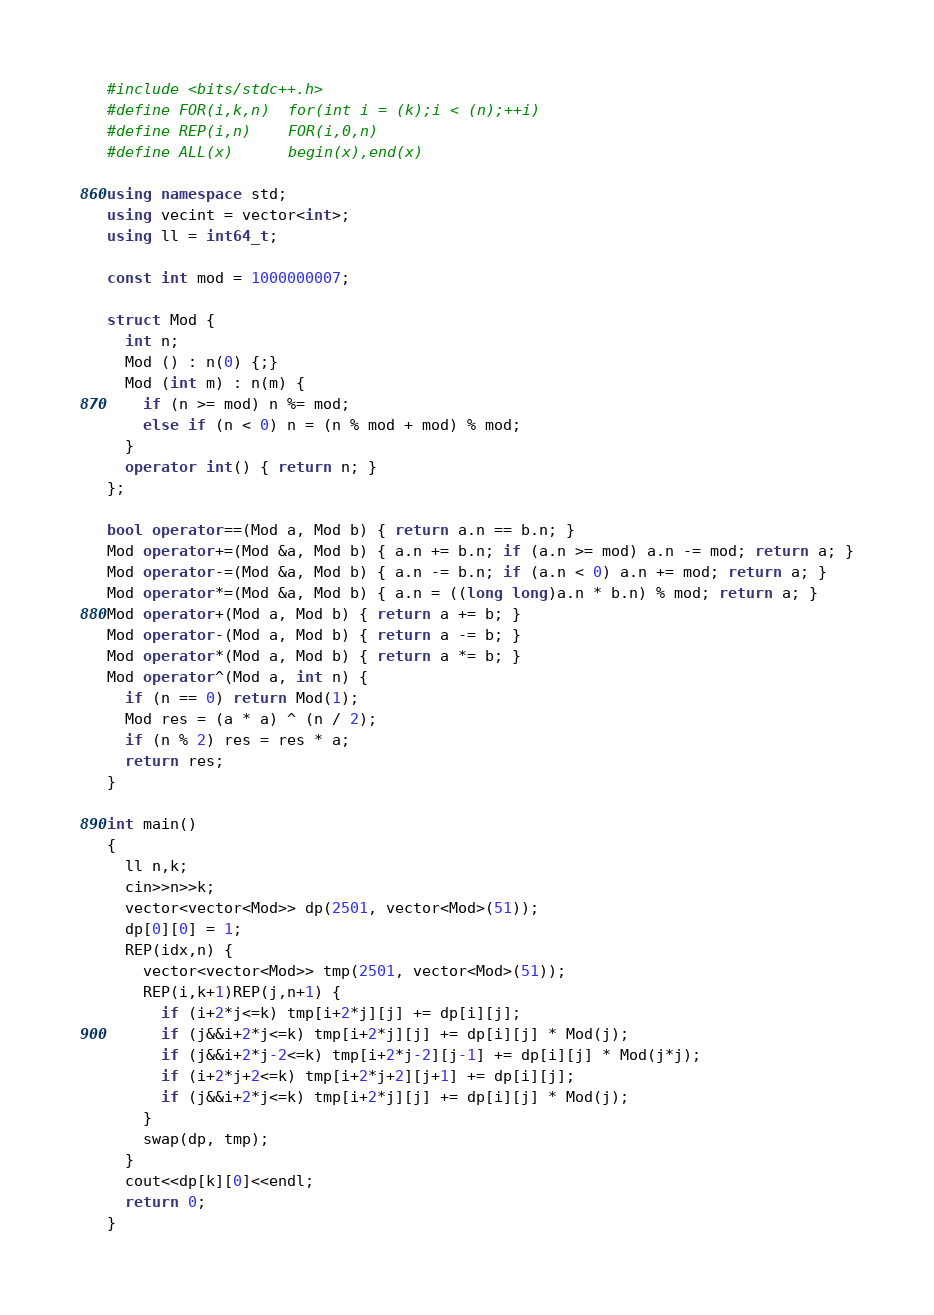<code> <loc_0><loc_0><loc_500><loc_500><_C++_>#include <bits/stdc++.h>
#define FOR(i,k,n)  for(int i = (k);i < (n);++i)
#define REP(i,n)    FOR(i,0,n)
#define ALL(x)      begin(x),end(x)

using namespace std;
using vecint = vector<int>;
using ll = int64_t;

const int mod = 1000000007;

struct Mod {
  int n;
  Mod () : n(0) {;}
  Mod (int m) : n(m) {
    if (n >= mod) n %= mod;
    else if (n < 0) n = (n % mod + mod) % mod;
  }
  operator int() { return n; }
};

bool operator==(Mod a, Mod b) { return a.n == b.n; }
Mod operator+=(Mod &a, Mod b) { a.n += b.n; if (a.n >= mod) a.n -= mod; return a; }
Mod operator-=(Mod &a, Mod b) { a.n -= b.n; if (a.n < 0) a.n += mod; return a; }
Mod operator*=(Mod &a, Mod b) { a.n = ((long long)a.n * b.n) % mod; return a; }
Mod operator+(Mod a, Mod b) { return a += b; }
Mod operator-(Mod a, Mod b) { return a -= b; }
Mod operator*(Mod a, Mod b) { return a *= b; }
Mod operator^(Mod a, int n) {
  if (n == 0) return Mod(1);
  Mod res = (a * a) ^ (n / 2);
  if (n % 2) res = res * a;
  return res;
}

int main()
{
  ll n,k;
  cin>>n>>k;
  vector<vector<Mod>> dp(2501, vector<Mod>(51));
  dp[0][0] = 1;
  REP(idx,n) {
    vector<vector<Mod>> tmp(2501, vector<Mod>(51));
    REP(i,k+1)REP(j,n+1) {
      if (i+2*j<=k) tmp[i+2*j][j] += dp[i][j];
      if (j&&i+2*j<=k) tmp[i+2*j][j] += dp[i][j] * Mod(j);
      if (j&&i+2*j-2<=k) tmp[i+2*j-2][j-1] += dp[i][j] * Mod(j*j);
      if (i+2*j+2<=k) tmp[i+2*j+2][j+1] += dp[i][j];
      if (j&&i+2*j<=k) tmp[i+2*j][j] += dp[i][j] * Mod(j);
    }
    swap(dp, tmp);
  }
  cout<<dp[k][0]<<endl;
  return 0;
}
</code> 